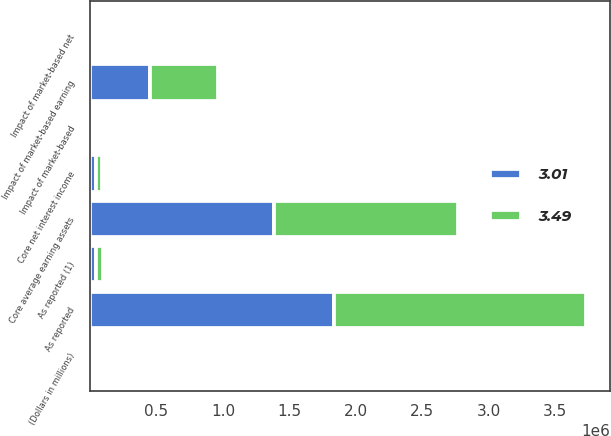Convert chart to OTSL. <chart><loc_0><loc_0><loc_500><loc_500><stacked_bar_chart><ecel><fcel>(Dollars in millions)<fcel>As reported (1)<fcel>Impact of market-based net<fcel>Core net interest income<fcel>As reported<fcel>Impact of market-based earning<fcel>Core average earning assets<fcel>Impact of market-based<nl><fcel>3.01<fcel>2011<fcel>45588<fcel>3813<fcel>41775<fcel>1.83466e+06<fcel>448776<fcel>1.38588e+06<fcel>0.53<nl><fcel>3.49<fcel>2010<fcel>52693<fcel>4430<fcel>48263<fcel>1.89757e+06<fcel>512804<fcel>1.38477e+06<fcel>0.71<nl></chart> 